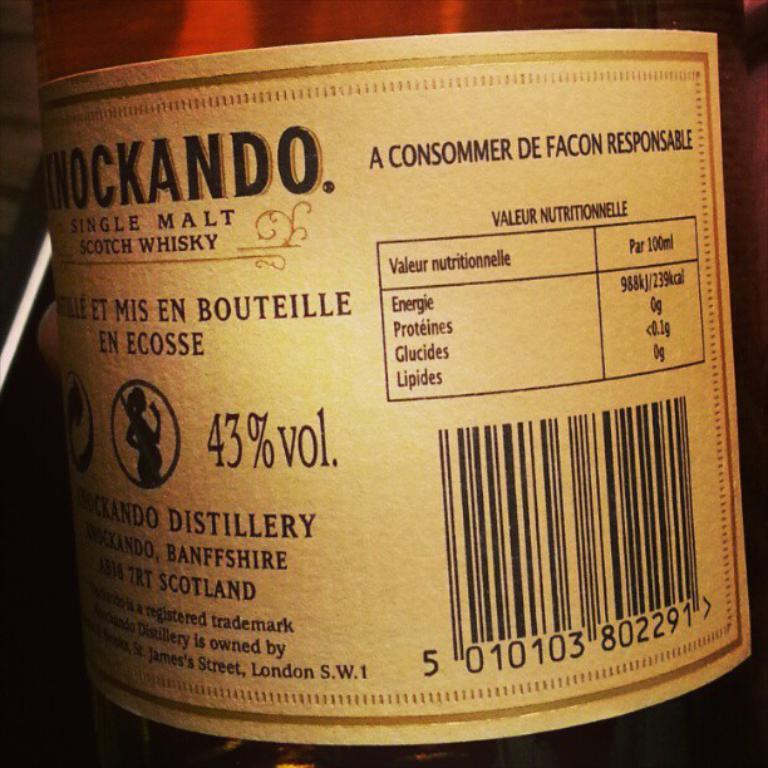Provide a one-sentence caption for the provided image. A label for malt whiskey gives nutrition information. 